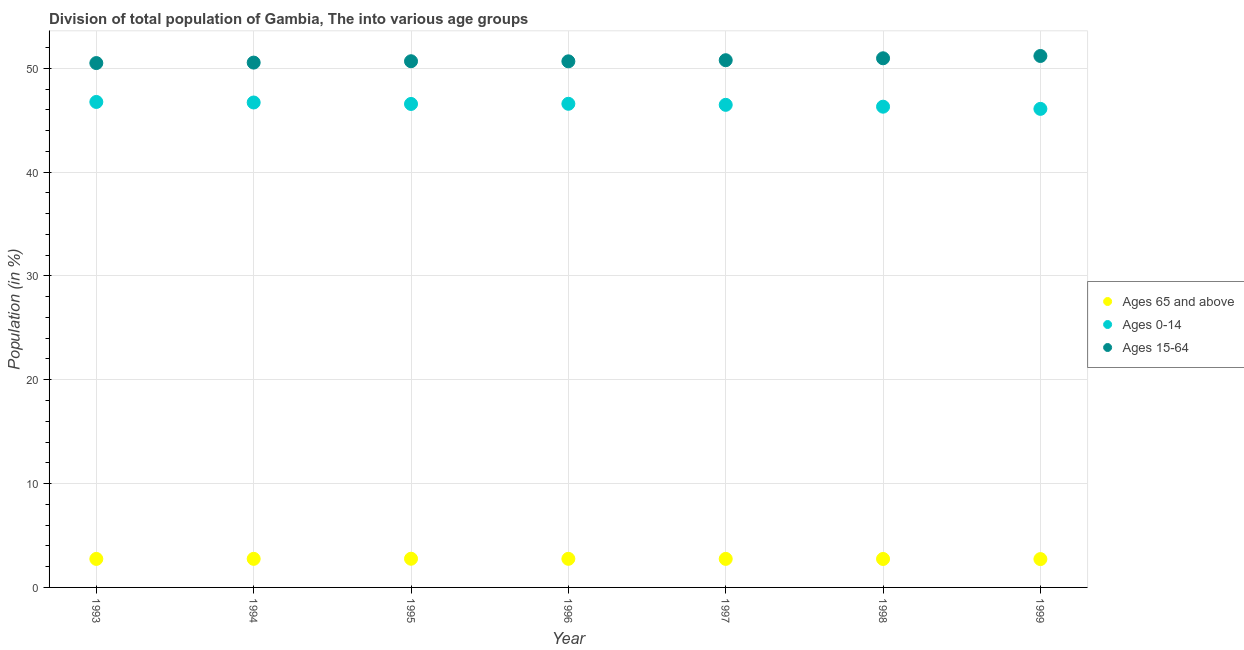How many different coloured dotlines are there?
Give a very brief answer. 3. What is the percentage of population within the age-group of 65 and above in 1997?
Provide a short and direct response. 2.75. Across all years, what is the maximum percentage of population within the age-group 0-14?
Your answer should be very brief. 46.75. Across all years, what is the minimum percentage of population within the age-group of 65 and above?
Ensure brevity in your answer.  2.73. In which year was the percentage of population within the age-group of 65 and above maximum?
Offer a very short reply. 1995. What is the total percentage of population within the age-group 0-14 in the graph?
Offer a terse response. 325.46. What is the difference between the percentage of population within the age-group 0-14 in 1993 and that in 1998?
Your answer should be very brief. 0.46. What is the difference between the percentage of population within the age-group of 65 and above in 1994 and the percentage of population within the age-group 15-64 in 1998?
Give a very brief answer. -48.21. What is the average percentage of population within the age-group 15-64 per year?
Keep it short and to the point. 50.76. In the year 1999, what is the difference between the percentage of population within the age-group 15-64 and percentage of population within the age-group of 65 and above?
Make the answer very short. 48.45. In how many years, is the percentage of population within the age-group of 65 and above greater than 28 %?
Provide a short and direct response. 0. What is the ratio of the percentage of population within the age-group 0-14 in 1994 to that in 1997?
Your answer should be compact. 1. Is the difference between the percentage of population within the age-group 15-64 in 1994 and 1996 greater than the difference between the percentage of population within the age-group 0-14 in 1994 and 1996?
Offer a terse response. No. What is the difference between the highest and the second highest percentage of population within the age-group of 65 and above?
Offer a very short reply. 0.01. What is the difference between the highest and the lowest percentage of population within the age-group 0-14?
Offer a very short reply. 0.67. In how many years, is the percentage of population within the age-group 0-14 greater than the average percentage of population within the age-group 0-14 taken over all years?
Your answer should be very brief. 4. Is the sum of the percentage of population within the age-group 0-14 in 1993 and 1996 greater than the maximum percentage of population within the age-group of 65 and above across all years?
Your answer should be compact. Yes. Is the percentage of population within the age-group 15-64 strictly greater than the percentage of population within the age-group 0-14 over the years?
Make the answer very short. Yes. Is the percentage of population within the age-group 15-64 strictly less than the percentage of population within the age-group 0-14 over the years?
Offer a very short reply. No. How many dotlines are there?
Keep it short and to the point. 3. What is the difference between two consecutive major ticks on the Y-axis?
Provide a succinct answer. 10. Does the graph contain any zero values?
Your answer should be very brief. No. Does the graph contain grids?
Make the answer very short. Yes. Where does the legend appear in the graph?
Make the answer very short. Center right. What is the title of the graph?
Make the answer very short. Division of total population of Gambia, The into various age groups
. What is the label or title of the X-axis?
Give a very brief answer. Year. What is the Population (in %) in Ages 65 and above in 1993?
Your response must be concise. 2.75. What is the Population (in %) in Ages 0-14 in 1993?
Your answer should be very brief. 46.75. What is the Population (in %) in Ages 15-64 in 1993?
Make the answer very short. 50.5. What is the Population (in %) of Ages 65 and above in 1994?
Provide a short and direct response. 2.75. What is the Population (in %) of Ages 0-14 in 1994?
Make the answer very short. 46.7. What is the Population (in %) in Ages 15-64 in 1994?
Your answer should be compact. 50.54. What is the Population (in %) in Ages 65 and above in 1995?
Ensure brevity in your answer.  2.76. What is the Population (in %) of Ages 0-14 in 1995?
Offer a very short reply. 46.56. What is the Population (in %) in Ages 15-64 in 1995?
Keep it short and to the point. 50.67. What is the Population (in %) in Ages 65 and above in 1996?
Give a very brief answer. 2.76. What is the Population (in %) of Ages 0-14 in 1996?
Ensure brevity in your answer.  46.58. What is the Population (in %) of Ages 15-64 in 1996?
Make the answer very short. 50.67. What is the Population (in %) of Ages 65 and above in 1997?
Your response must be concise. 2.75. What is the Population (in %) of Ages 0-14 in 1997?
Keep it short and to the point. 46.48. What is the Population (in %) in Ages 15-64 in 1997?
Make the answer very short. 50.77. What is the Population (in %) in Ages 65 and above in 1998?
Your answer should be very brief. 2.74. What is the Population (in %) in Ages 0-14 in 1998?
Give a very brief answer. 46.3. What is the Population (in %) of Ages 15-64 in 1998?
Keep it short and to the point. 50.96. What is the Population (in %) of Ages 65 and above in 1999?
Your answer should be very brief. 2.73. What is the Population (in %) in Ages 0-14 in 1999?
Make the answer very short. 46.09. What is the Population (in %) in Ages 15-64 in 1999?
Your response must be concise. 51.18. Across all years, what is the maximum Population (in %) of Ages 65 and above?
Offer a terse response. 2.76. Across all years, what is the maximum Population (in %) in Ages 0-14?
Make the answer very short. 46.75. Across all years, what is the maximum Population (in %) in Ages 15-64?
Ensure brevity in your answer.  51.18. Across all years, what is the minimum Population (in %) in Ages 65 and above?
Ensure brevity in your answer.  2.73. Across all years, what is the minimum Population (in %) of Ages 0-14?
Your answer should be very brief. 46.09. Across all years, what is the minimum Population (in %) in Ages 15-64?
Your response must be concise. 50.5. What is the total Population (in %) in Ages 65 and above in the graph?
Your answer should be compact. 19.24. What is the total Population (in %) in Ages 0-14 in the graph?
Your response must be concise. 325.46. What is the total Population (in %) in Ages 15-64 in the graph?
Make the answer very short. 355.3. What is the difference between the Population (in %) of Ages 65 and above in 1993 and that in 1994?
Give a very brief answer. -0.01. What is the difference between the Population (in %) in Ages 0-14 in 1993 and that in 1994?
Provide a succinct answer. 0.05. What is the difference between the Population (in %) of Ages 15-64 in 1993 and that in 1994?
Provide a succinct answer. -0.05. What is the difference between the Population (in %) of Ages 65 and above in 1993 and that in 1995?
Provide a succinct answer. -0.02. What is the difference between the Population (in %) in Ages 0-14 in 1993 and that in 1995?
Your answer should be very brief. 0.19. What is the difference between the Population (in %) in Ages 15-64 in 1993 and that in 1995?
Ensure brevity in your answer.  -0.18. What is the difference between the Population (in %) of Ages 65 and above in 1993 and that in 1996?
Provide a short and direct response. -0.01. What is the difference between the Population (in %) in Ages 0-14 in 1993 and that in 1996?
Your answer should be very brief. 0.18. What is the difference between the Population (in %) of Ages 15-64 in 1993 and that in 1996?
Offer a very short reply. -0.17. What is the difference between the Population (in %) in Ages 65 and above in 1993 and that in 1997?
Your response must be concise. -0. What is the difference between the Population (in %) in Ages 0-14 in 1993 and that in 1997?
Ensure brevity in your answer.  0.28. What is the difference between the Population (in %) in Ages 15-64 in 1993 and that in 1997?
Give a very brief answer. -0.28. What is the difference between the Population (in %) in Ages 65 and above in 1993 and that in 1998?
Keep it short and to the point. 0.01. What is the difference between the Population (in %) in Ages 0-14 in 1993 and that in 1998?
Your response must be concise. 0.46. What is the difference between the Population (in %) of Ages 15-64 in 1993 and that in 1998?
Your response must be concise. -0.46. What is the difference between the Population (in %) in Ages 65 and above in 1993 and that in 1999?
Offer a very short reply. 0.02. What is the difference between the Population (in %) of Ages 0-14 in 1993 and that in 1999?
Keep it short and to the point. 0.67. What is the difference between the Population (in %) in Ages 15-64 in 1993 and that in 1999?
Give a very brief answer. -0.68. What is the difference between the Population (in %) in Ages 65 and above in 1994 and that in 1995?
Your answer should be compact. -0.01. What is the difference between the Population (in %) in Ages 0-14 in 1994 and that in 1995?
Keep it short and to the point. 0.14. What is the difference between the Population (in %) in Ages 15-64 in 1994 and that in 1995?
Your response must be concise. -0.13. What is the difference between the Population (in %) in Ages 65 and above in 1994 and that in 1996?
Your response must be concise. -0. What is the difference between the Population (in %) of Ages 0-14 in 1994 and that in 1996?
Keep it short and to the point. 0.12. What is the difference between the Population (in %) of Ages 15-64 in 1994 and that in 1996?
Your answer should be compact. -0.12. What is the difference between the Population (in %) of Ages 65 and above in 1994 and that in 1997?
Provide a succinct answer. 0. What is the difference between the Population (in %) in Ages 0-14 in 1994 and that in 1997?
Provide a succinct answer. 0.23. What is the difference between the Population (in %) of Ages 15-64 in 1994 and that in 1997?
Your response must be concise. -0.23. What is the difference between the Population (in %) in Ages 65 and above in 1994 and that in 1998?
Offer a terse response. 0.01. What is the difference between the Population (in %) of Ages 0-14 in 1994 and that in 1998?
Ensure brevity in your answer.  0.4. What is the difference between the Population (in %) of Ages 15-64 in 1994 and that in 1998?
Your response must be concise. -0.42. What is the difference between the Population (in %) in Ages 65 and above in 1994 and that in 1999?
Keep it short and to the point. 0.02. What is the difference between the Population (in %) in Ages 0-14 in 1994 and that in 1999?
Make the answer very short. 0.61. What is the difference between the Population (in %) in Ages 15-64 in 1994 and that in 1999?
Keep it short and to the point. -0.64. What is the difference between the Population (in %) in Ages 65 and above in 1995 and that in 1996?
Ensure brevity in your answer.  0.01. What is the difference between the Population (in %) in Ages 0-14 in 1995 and that in 1996?
Provide a succinct answer. -0.02. What is the difference between the Population (in %) of Ages 15-64 in 1995 and that in 1996?
Your answer should be very brief. 0.01. What is the difference between the Population (in %) of Ages 65 and above in 1995 and that in 1997?
Offer a very short reply. 0.01. What is the difference between the Population (in %) of Ages 0-14 in 1995 and that in 1997?
Ensure brevity in your answer.  0.09. What is the difference between the Population (in %) in Ages 15-64 in 1995 and that in 1997?
Your answer should be very brief. -0.1. What is the difference between the Population (in %) of Ages 65 and above in 1995 and that in 1998?
Offer a very short reply. 0.02. What is the difference between the Population (in %) in Ages 0-14 in 1995 and that in 1998?
Keep it short and to the point. 0.26. What is the difference between the Population (in %) in Ages 15-64 in 1995 and that in 1998?
Make the answer very short. -0.29. What is the difference between the Population (in %) in Ages 65 and above in 1995 and that in 1999?
Offer a terse response. 0.03. What is the difference between the Population (in %) in Ages 0-14 in 1995 and that in 1999?
Offer a very short reply. 0.47. What is the difference between the Population (in %) in Ages 15-64 in 1995 and that in 1999?
Your response must be concise. -0.51. What is the difference between the Population (in %) in Ages 65 and above in 1996 and that in 1997?
Provide a succinct answer. 0.01. What is the difference between the Population (in %) in Ages 0-14 in 1996 and that in 1997?
Provide a short and direct response. 0.1. What is the difference between the Population (in %) in Ages 15-64 in 1996 and that in 1997?
Make the answer very short. -0.11. What is the difference between the Population (in %) in Ages 65 and above in 1996 and that in 1998?
Your answer should be compact. 0.01. What is the difference between the Population (in %) of Ages 0-14 in 1996 and that in 1998?
Keep it short and to the point. 0.28. What is the difference between the Population (in %) of Ages 15-64 in 1996 and that in 1998?
Keep it short and to the point. -0.29. What is the difference between the Population (in %) of Ages 65 and above in 1996 and that in 1999?
Offer a very short reply. 0.03. What is the difference between the Population (in %) of Ages 0-14 in 1996 and that in 1999?
Offer a very short reply. 0.49. What is the difference between the Population (in %) in Ages 15-64 in 1996 and that in 1999?
Offer a terse response. -0.52. What is the difference between the Population (in %) of Ages 65 and above in 1997 and that in 1998?
Offer a very short reply. 0.01. What is the difference between the Population (in %) of Ages 0-14 in 1997 and that in 1998?
Your answer should be compact. 0.18. What is the difference between the Population (in %) in Ages 15-64 in 1997 and that in 1998?
Your response must be concise. -0.19. What is the difference between the Population (in %) in Ages 65 and above in 1997 and that in 1999?
Your answer should be compact. 0.02. What is the difference between the Population (in %) of Ages 0-14 in 1997 and that in 1999?
Offer a very short reply. 0.39. What is the difference between the Population (in %) in Ages 15-64 in 1997 and that in 1999?
Provide a short and direct response. -0.41. What is the difference between the Population (in %) in Ages 65 and above in 1998 and that in 1999?
Ensure brevity in your answer.  0.01. What is the difference between the Population (in %) in Ages 0-14 in 1998 and that in 1999?
Your answer should be very brief. 0.21. What is the difference between the Population (in %) of Ages 15-64 in 1998 and that in 1999?
Offer a terse response. -0.22. What is the difference between the Population (in %) in Ages 65 and above in 1993 and the Population (in %) in Ages 0-14 in 1994?
Offer a terse response. -43.96. What is the difference between the Population (in %) in Ages 65 and above in 1993 and the Population (in %) in Ages 15-64 in 1994?
Give a very brief answer. -47.8. What is the difference between the Population (in %) of Ages 0-14 in 1993 and the Population (in %) of Ages 15-64 in 1994?
Your response must be concise. -3.79. What is the difference between the Population (in %) in Ages 65 and above in 1993 and the Population (in %) in Ages 0-14 in 1995?
Keep it short and to the point. -43.82. What is the difference between the Population (in %) in Ages 65 and above in 1993 and the Population (in %) in Ages 15-64 in 1995?
Give a very brief answer. -47.93. What is the difference between the Population (in %) in Ages 0-14 in 1993 and the Population (in %) in Ages 15-64 in 1995?
Your answer should be very brief. -3.92. What is the difference between the Population (in %) in Ages 65 and above in 1993 and the Population (in %) in Ages 0-14 in 1996?
Ensure brevity in your answer.  -43.83. What is the difference between the Population (in %) in Ages 65 and above in 1993 and the Population (in %) in Ages 15-64 in 1996?
Ensure brevity in your answer.  -47.92. What is the difference between the Population (in %) of Ages 0-14 in 1993 and the Population (in %) of Ages 15-64 in 1996?
Ensure brevity in your answer.  -3.91. What is the difference between the Population (in %) of Ages 65 and above in 1993 and the Population (in %) of Ages 0-14 in 1997?
Provide a succinct answer. -43.73. What is the difference between the Population (in %) of Ages 65 and above in 1993 and the Population (in %) of Ages 15-64 in 1997?
Your response must be concise. -48.03. What is the difference between the Population (in %) in Ages 0-14 in 1993 and the Population (in %) in Ages 15-64 in 1997?
Make the answer very short. -4.02. What is the difference between the Population (in %) in Ages 65 and above in 1993 and the Population (in %) in Ages 0-14 in 1998?
Your response must be concise. -43.55. What is the difference between the Population (in %) of Ages 65 and above in 1993 and the Population (in %) of Ages 15-64 in 1998?
Give a very brief answer. -48.21. What is the difference between the Population (in %) of Ages 0-14 in 1993 and the Population (in %) of Ages 15-64 in 1998?
Your response must be concise. -4.21. What is the difference between the Population (in %) in Ages 65 and above in 1993 and the Population (in %) in Ages 0-14 in 1999?
Provide a short and direct response. -43.34. What is the difference between the Population (in %) of Ages 65 and above in 1993 and the Population (in %) of Ages 15-64 in 1999?
Keep it short and to the point. -48.44. What is the difference between the Population (in %) in Ages 0-14 in 1993 and the Population (in %) in Ages 15-64 in 1999?
Ensure brevity in your answer.  -4.43. What is the difference between the Population (in %) in Ages 65 and above in 1994 and the Population (in %) in Ages 0-14 in 1995?
Ensure brevity in your answer.  -43.81. What is the difference between the Population (in %) of Ages 65 and above in 1994 and the Population (in %) of Ages 15-64 in 1995?
Offer a terse response. -47.92. What is the difference between the Population (in %) of Ages 0-14 in 1994 and the Population (in %) of Ages 15-64 in 1995?
Make the answer very short. -3.97. What is the difference between the Population (in %) in Ages 65 and above in 1994 and the Population (in %) in Ages 0-14 in 1996?
Offer a very short reply. -43.83. What is the difference between the Population (in %) in Ages 65 and above in 1994 and the Population (in %) in Ages 15-64 in 1996?
Your response must be concise. -47.91. What is the difference between the Population (in %) of Ages 0-14 in 1994 and the Population (in %) of Ages 15-64 in 1996?
Provide a succinct answer. -3.96. What is the difference between the Population (in %) in Ages 65 and above in 1994 and the Population (in %) in Ages 0-14 in 1997?
Offer a terse response. -43.72. What is the difference between the Population (in %) of Ages 65 and above in 1994 and the Population (in %) of Ages 15-64 in 1997?
Ensure brevity in your answer.  -48.02. What is the difference between the Population (in %) of Ages 0-14 in 1994 and the Population (in %) of Ages 15-64 in 1997?
Make the answer very short. -4.07. What is the difference between the Population (in %) in Ages 65 and above in 1994 and the Population (in %) in Ages 0-14 in 1998?
Offer a very short reply. -43.55. What is the difference between the Population (in %) in Ages 65 and above in 1994 and the Population (in %) in Ages 15-64 in 1998?
Give a very brief answer. -48.21. What is the difference between the Population (in %) in Ages 0-14 in 1994 and the Population (in %) in Ages 15-64 in 1998?
Provide a short and direct response. -4.26. What is the difference between the Population (in %) in Ages 65 and above in 1994 and the Population (in %) in Ages 0-14 in 1999?
Give a very brief answer. -43.34. What is the difference between the Population (in %) of Ages 65 and above in 1994 and the Population (in %) of Ages 15-64 in 1999?
Make the answer very short. -48.43. What is the difference between the Population (in %) in Ages 0-14 in 1994 and the Population (in %) in Ages 15-64 in 1999?
Provide a short and direct response. -4.48. What is the difference between the Population (in %) of Ages 65 and above in 1995 and the Population (in %) of Ages 0-14 in 1996?
Provide a short and direct response. -43.81. What is the difference between the Population (in %) in Ages 65 and above in 1995 and the Population (in %) in Ages 15-64 in 1996?
Your answer should be very brief. -47.9. What is the difference between the Population (in %) of Ages 0-14 in 1995 and the Population (in %) of Ages 15-64 in 1996?
Provide a short and direct response. -4.1. What is the difference between the Population (in %) in Ages 65 and above in 1995 and the Population (in %) in Ages 0-14 in 1997?
Offer a terse response. -43.71. What is the difference between the Population (in %) of Ages 65 and above in 1995 and the Population (in %) of Ages 15-64 in 1997?
Your answer should be compact. -48.01. What is the difference between the Population (in %) of Ages 0-14 in 1995 and the Population (in %) of Ages 15-64 in 1997?
Make the answer very short. -4.21. What is the difference between the Population (in %) of Ages 65 and above in 1995 and the Population (in %) of Ages 0-14 in 1998?
Offer a terse response. -43.54. What is the difference between the Population (in %) of Ages 65 and above in 1995 and the Population (in %) of Ages 15-64 in 1998?
Your answer should be very brief. -48.2. What is the difference between the Population (in %) of Ages 0-14 in 1995 and the Population (in %) of Ages 15-64 in 1998?
Your response must be concise. -4.4. What is the difference between the Population (in %) of Ages 65 and above in 1995 and the Population (in %) of Ages 0-14 in 1999?
Your response must be concise. -43.33. What is the difference between the Population (in %) in Ages 65 and above in 1995 and the Population (in %) in Ages 15-64 in 1999?
Ensure brevity in your answer.  -48.42. What is the difference between the Population (in %) of Ages 0-14 in 1995 and the Population (in %) of Ages 15-64 in 1999?
Offer a very short reply. -4.62. What is the difference between the Population (in %) in Ages 65 and above in 1996 and the Population (in %) in Ages 0-14 in 1997?
Offer a terse response. -43.72. What is the difference between the Population (in %) in Ages 65 and above in 1996 and the Population (in %) in Ages 15-64 in 1997?
Your response must be concise. -48.02. What is the difference between the Population (in %) in Ages 0-14 in 1996 and the Population (in %) in Ages 15-64 in 1997?
Provide a succinct answer. -4.2. What is the difference between the Population (in %) in Ages 65 and above in 1996 and the Population (in %) in Ages 0-14 in 1998?
Your response must be concise. -43.54. What is the difference between the Population (in %) in Ages 65 and above in 1996 and the Population (in %) in Ages 15-64 in 1998?
Give a very brief answer. -48.2. What is the difference between the Population (in %) in Ages 0-14 in 1996 and the Population (in %) in Ages 15-64 in 1998?
Offer a very short reply. -4.38. What is the difference between the Population (in %) in Ages 65 and above in 1996 and the Population (in %) in Ages 0-14 in 1999?
Make the answer very short. -43.33. What is the difference between the Population (in %) in Ages 65 and above in 1996 and the Population (in %) in Ages 15-64 in 1999?
Provide a succinct answer. -48.43. What is the difference between the Population (in %) in Ages 0-14 in 1996 and the Population (in %) in Ages 15-64 in 1999?
Make the answer very short. -4.6. What is the difference between the Population (in %) of Ages 65 and above in 1997 and the Population (in %) of Ages 0-14 in 1998?
Keep it short and to the point. -43.55. What is the difference between the Population (in %) of Ages 65 and above in 1997 and the Population (in %) of Ages 15-64 in 1998?
Make the answer very short. -48.21. What is the difference between the Population (in %) of Ages 0-14 in 1997 and the Population (in %) of Ages 15-64 in 1998?
Give a very brief answer. -4.48. What is the difference between the Population (in %) in Ages 65 and above in 1997 and the Population (in %) in Ages 0-14 in 1999?
Give a very brief answer. -43.34. What is the difference between the Population (in %) of Ages 65 and above in 1997 and the Population (in %) of Ages 15-64 in 1999?
Provide a succinct answer. -48.43. What is the difference between the Population (in %) of Ages 0-14 in 1997 and the Population (in %) of Ages 15-64 in 1999?
Offer a terse response. -4.71. What is the difference between the Population (in %) of Ages 65 and above in 1998 and the Population (in %) of Ages 0-14 in 1999?
Your response must be concise. -43.35. What is the difference between the Population (in %) in Ages 65 and above in 1998 and the Population (in %) in Ages 15-64 in 1999?
Make the answer very short. -48.44. What is the difference between the Population (in %) in Ages 0-14 in 1998 and the Population (in %) in Ages 15-64 in 1999?
Give a very brief answer. -4.88. What is the average Population (in %) in Ages 65 and above per year?
Give a very brief answer. 2.75. What is the average Population (in %) of Ages 0-14 per year?
Provide a succinct answer. 46.49. What is the average Population (in %) in Ages 15-64 per year?
Give a very brief answer. 50.76. In the year 1993, what is the difference between the Population (in %) in Ages 65 and above and Population (in %) in Ages 0-14?
Your answer should be very brief. -44.01. In the year 1993, what is the difference between the Population (in %) of Ages 65 and above and Population (in %) of Ages 15-64?
Ensure brevity in your answer.  -47.75. In the year 1993, what is the difference between the Population (in %) of Ages 0-14 and Population (in %) of Ages 15-64?
Your answer should be very brief. -3.74. In the year 1994, what is the difference between the Population (in %) in Ages 65 and above and Population (in %) in Ages 0-14?
Provide a short and direct response. -43.95. In the year 1994, what is the difference between the Population (in %) of Ages 65 and above and Population (in %) of Ages 15-64?
Give a very brief answer. -47.79. In the year 1994, what is the difference between the Population (in %) of Ages 0-14 and Population (in %) of Ages 15-64?
Keep it short and to the point. -3.84. In the year 1995, what is the difference between the Population (in %) of Ages 65 and above and Population (in %) of Ages 0-14?
Offer a very short reply. -43.8. In the year 1995, what is the difference between the Population (in %) of Ages 65 and above and Population (in %) of Ages 15-64?
Provide a succinct answer. -47.91. In the year 1995, what is the difference between the Population (in %) in Ages 0-14 and Population (in %) in Ages 15-64?
Offer a very short reply. -4.11. In the year 1996, what is the difference between the Population (in %) in Ages 65 and above and Population (in %) in Ages 0-14?
Make the answer very short. -43.82. In the year 1996, what is the difference between the Population (in %) of Ages 65 and above and Population (in %) of Ages 15-64?
Keep it short and to the point. -47.91. In the year 1996, what is the difference between the Population (in %) of Ages 0-14 and Population (in %) of Ages 15-64?
Make the answer very short. -4.09. In the year 1997, what is the difference between the Population (in %) of Ages 65 and above and Population (in %) of Ages 0-14?
Your response must be concise. -43.73. In the year 1997, what is the difference between the Population (in %) of Ages 65 and above and Population (in %) of Ages 15-64?
Your response must be concise. -48.03. In the year 1997, what is the difference between the Population (in %) of Ages 0-14 and Population (in %) of Ages 15-64?
Make the answer very short. -4.3. In the year 1998, what is the difference between the Population (in %) of Ages 65 and above and Population (in %) of Ages 0-14?
Provide a short and direct response. -43.56. In the year 1998, what is the difference between the Population (in %) of Ages 65 and above and Population (in %) of Ages 15-64?
Make the answer very short. -48.22. In the year 1998, what is the difference between the Population (in %) in Ages 0-14 and Population (in %) in Ages 15-64?
Offer a very short reply. -4.66. In the year 1999, what is the difference between the Population (in %) in Ages 65 and above and Population (in %) in Ages 0-14?
Offer a very short reply. -43.36. In the year 1999, what is the difference between the Population (in %) of Ages 65 and above and Population (in %) of Ages 15-64?
Ensure brevity in your answer.  -48.45. In the year 1999, what is the difference between the Population (in %) in Ages 0-14 and Population (in %) in Ages 15-64?
Offer a terse response. -5.09. What is the ratio of the Population (in %) in Ages 65 and above in 1993 to that in 1994?
Offer a terse response. 1. What is the ratio of the Population (in %) in Ages 0-14 in 1993 to that in 1995?
Ensure brevity in your answer.  1. What is the ratio of the Population (in %) in Ages 15-64 in 1993 to that in 1995?
Provide a succinct answer. 1. What is the ratio of the Population (in %) in Ages 65 and above in 1993 to that in 1996?
Provide a succinct answer. 1. What is the ratio of the Population (in %) in Ages 65 and above in 1993 to that in 1997?
Ensure brevity in your answer.  1. What is the ratio of the Population (in %) in Ages 15-64 in 1993 to that in 1997?
Ensure brevity in your answer.  0.99. What is the ratio of the Population (in %) in Ages 65 and above in 1993 to that in 1998?
Keep it short and to the point. 1. What is the ratio of the Population (in %) in Ages 0-14 in 1993 to that in 1998?
Your response must be concise. 1.01. What is the ratio of the Population (in %) in Ages 65 and above in 1993 to that in 1999?
Ensure brevity in your answer.  1.01. What is the ratio of the Population (in %) in Ages 0-14 in 1993 to that in 1999?
Offer a very short reply. 1.01. What is the ratio of the Population (in %) in Ages 15-64 in 1993 to that in 1999?
Provide a short and direct response. 0.99. What is the ratio of the Population (in %) of Ages 0-14 in 1994 to that in 1995?
Give a very brief answer. 1. What is the ratio of the Population (in %) of Ages 65 and above in 1994 to that in 1996?
Offer a very short reply. 1. What is the ratio of the Population (in %) of Ages 0-14 in 1994 to that in 1996?
Provide a succinct answer. 1. What is the ratio of the Population (in %) of Ages 0-14 in 1994 to that in 1998?
Your response must be concise. 1.01. What is the ratio of the Population (in %) in Ages 65 and above in 1994 to that in 1999?
Keep it short and to the point. 1.01. What is the ratio of the Population (in %) of Ages 0-14 in 1994 to that in 1999?
Your answer should be very brief. 1.01. What is the ratio of the Population (in %) in Ages 15-64 in 1994 to that in 1999?
Keep it short and to the point. 0.99. What is the ratio of the Population (in %) of Ages 0-14 in 1995 to that in 1996?
Ensure brevity in your answer.  1. What is the ratio of the Population (in %) in Ages 15-64 in 1995 to that in 1996?
Ensure brevity in your answer.  1. What is the ratio of the Population (in %) in Ages 65 and above in 1995 to that in 1997?
Offer a very short reply. 1.01. What is the ratio of the Population (in %) in Ages 0-14 in 1995 to that in 1997?
Keep it short and to the point. 1. What is the ratio of the Population (in %) of Ages 0-14 in 1995 to that in 1998?
Offer a terse response. 1.01. What is the ratio of the Population (in %) in Ages 15-64 in 1995 to that in 1998?
Give a very brief answer. 0.99. What is the ratio of the Population (in %) of Ages 65 and above in 1995 to that in 1999?
Provide a succinct answer. 1.01. What is the ratio of the Population (in %) in Ages 0-14 in 1995 to that in 1999?
Your answer should be compact. 1.01. What is the ratio of the Population (in %) of Ages 15-64 in 1995 to that in 1999?
Offer a very short reply. 0.99. What is the ratio of the Population (in %) in Ages 65 and above in 1996 to that in 1997?
Provide a short and direct response. 1. What is the ratio of the Population (in %) of Ages 15-64 in 1996 to that in 1997?
Provide a succinct answer. 1. What is the ratio of the Population (in %) of Ages 0-14 in 1996 to that in 1998?
Keep it short and to the point. 1.01. What is the ratio of the Population (in %) in Ages 65 and above in 1996 to that in 1999?
Your response must be concise. 1.01. What is the ratio of the Population (in %) of Ages 0-14 in 1996 to that in 1999?
Provide a succinct answer. 1.01. What is the ratio of the Population (in %) in Ages 65 and above in 1997 to that in 1998?
Your answer should be very brief. 1. What is the ratio of the Population (in %) in Ages 0-14 in 1997 to that in 1998?
Make the answer very short. 1. What is the ratio of the Population (in %) of Ages 15-64 in 1997 to that in 1998?
Your answer should be compact. 1. What is the ratio of the Population (in %) in Ages 65 and above in 1997 to that in 1999?
Provide a succinct answer. 1.01. What is the ratio of the Population (in %) in Ages 0-14 in 1997 to that in 1999?
Provide a short and direct response. 1.01. What is the ratio of the Population (in %) in Ages 65 and above in 1998 to that in 1999?
Ensure brevity in your answer.  1. What is the ratio of the Population (in %) of Ages 0-14 in 1998 to that in 1999?
Your response must be concise. 1. What is the difference between the highest and the second highest Population (in %) of Ages 65 and above?
Your response must be concise. 0.01. What is the difference between the highest and the second highest Population (in %) in Ages 0-14?
Offer a very short reply. 0.05. What is the difference between the highest and the second highest Population (in %) in Ages 15-64?
Your answer should be very brief. 0.22. What is the difference between the highest and the lowest Population (in %) of Ages 65 and above?
Your answer should be compact. 0.03. What is the difference between the highest and the lowest Population (in %) of Ages 0-14?
Keep it short and to the point. 0.67. What is the difference between the highest and the lowest Population (in %) of Ages 15-64?
Your response must be concise. 0.68. 